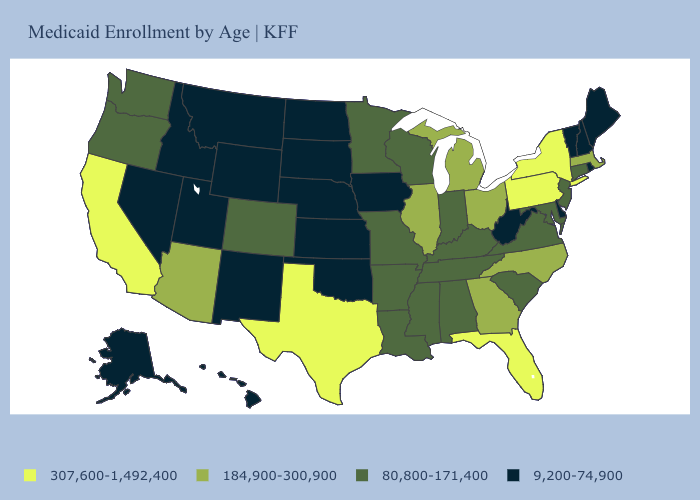Name the states that have a value in the range 307,600-1,492,400?
Give a very brief answer. California, Florida, New York, Pennsylvania, Texas. What is the highest value in the USA?
Concise answer only. 307,600-1,492,400. Does North Carolina have a lower value than New Jersey?
Give a very brief answer. No. What is the value of Kentucky?
Short answer required. 80,800-171,400. What is the value of California?
Short answer required. 307,600-1,492,400. What is the lowest value in the West?
Give a very brief answer. 9,200-74,900. Name the states that have a value in the range 80,800-171,400?
Write a very short answer. Alabama, Arkansas, Colorado, Connecticut, Indiana, Kentucky, Louisiana, Maryland, Minnesota, Mississippi, Missouri, New Jersey, Oregon, South Carolina, Tennessee, Virginia, Washington, Wisconsin. Does Alaska have the lowest value in the West?
Answer briefly. Yes. Among the states that border Arizona , which have the highest value?
Give a very brief answer. California. What is the value of Utah?
Write a very short answer. 9,200-74,900. Which states hav the highest value in the South?
Quick response, please. Florida, Texas. Which states hav the highest value in the MidWest?
Quick response, please. Illinois, Michigan, Ohio. Does Montana have the same value as Maine?
Write a very short answer. Yes. Name the states that have a value in the range 9,200-74,900?
Answer briefly. Alaska, Delaware, Hawaii, Idaho, Iowa, Kansas, Maine, Montana, Nebraska, Nevada, New Hampshire, New Mexico, North Dakota, Oklahoma, Rhode Island, South Dakota, Utah, Vermont, West Virginia, Wyoming. What is the value of Wisconsin?
Be succinct. 80,800-171,400. 